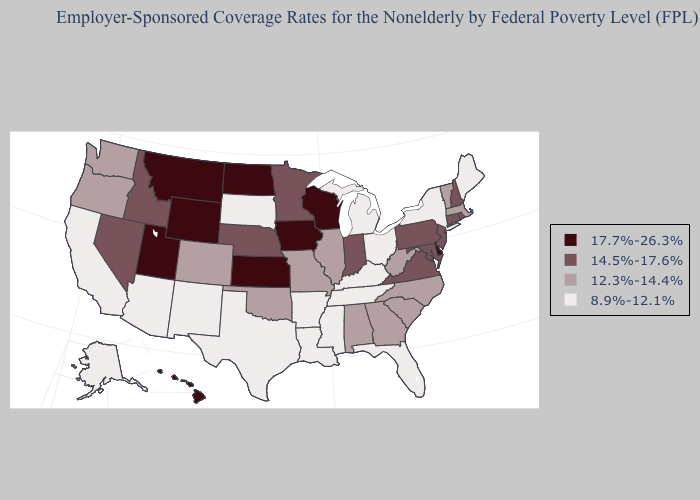Name the states that have a value in the range 12.3%-14.4%?
Keep it brief. Alabama, Colorado, Georgia, Illinois, Massachusetts, Missouri, North Carolina, Oklahoma, Oregon, South Carolina, Vermont, Washington, West Virginia. What is the highest value in the West ?
Give a very brief answer. 17.7%-26.3%. What is the lowest value in the USA?
Be succinct. 8.9%-12.1%. Does Arizona have a lower value than Maine?
Be succinct. No. Which states have the lowest value in the USA?
Give a very brief answer. Alaska, Arizona, Arkansas, California, Florida, Kentucky, Louisiana, Maine, Michigan, Mississippi, New Mexico, New York, Ohio, South Dakota, Tennessee, Texas. Among the states that border West Virginia , which have the lowest value?
Be succinct. Kentucky, Ohio. Name the states that have a value in the range 17.7%-26.3%?
Answer briefly. Delaware, Hawaii, Iowa, Kansas, Montana, North Dakota, Utah, Wisconsin, Wyoming. Among the states that border New Mexico , which have the lowest value?
Keep it brief. Arizona, Texas. Name the states that have a value in the range 8.9%-12.1%?
Keep it brief. Alaska, Arizona, Arkansas, California, Florida, Kentucky, Louisiana, Maine, Michigan, Mississippi, New Mexico, New York, Ohio, South Dakota, Tennessee, Texas. Which states hav the highest value in the South?
Answer briefly. Delaware. Name the states that have a value in the range 14.5%-17.6%?
Write a very short answer. Connecticut, Idaho, Indiana, Maryland, Minnesota, Nebraska, Nevada, New Hampshire, New Jersey, Pennsylvania, Rhode Island, Virginia. Name the states that have a value in the range 12.3%-14.4%?
Answer briefly. Alabama, Colorado, Georgia, Illinois, Massachusetts, Missouri, North Carolina, Oklahoma, Oregon, South Carolina, Vermont, Washington, West Virginia. Does Tennessee have the lowest value in the South?
Give a very brief answer. Yes. Which states have the lowest value in the MidWest?
Concise answer only. Michigan, Ohio, South Dakota. What is the value of New Jersey?
Short answer required. 14.5%-17.6%. 